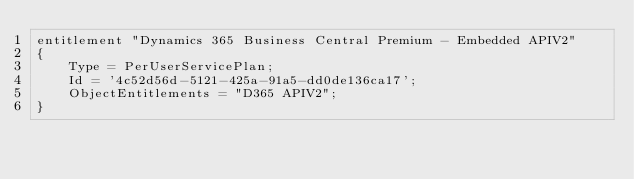Convert code to text. <code><loc_0><loc_0><loc_500><loc_500><_Perl_>entitlement "Dynamics 365 Business Central Premium - Embedded APIV2"
{
    Type = PerUserServicePlan;
    Id = '4c52d56d-5121-425a-91a5-dd0de136ca17';
    ObjectEntitlements = "D365 APIV2";
}
</code> 